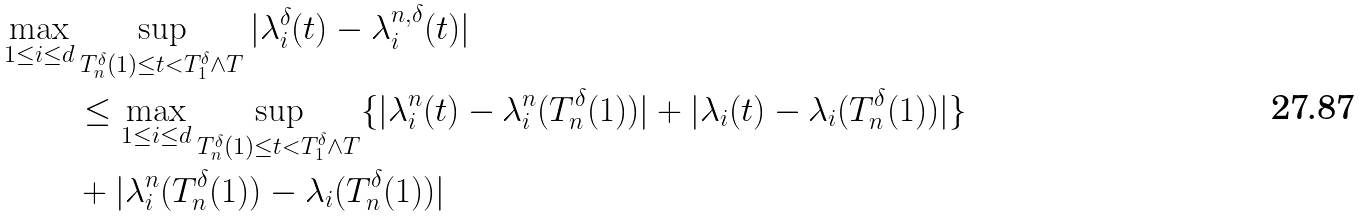Convert formula to latex. <formula><loc_0><loc_0><loc_500><loc_500>\max _ { 1 \leq i \leq d } & \sup _ { T _ { n } ^ { \delta } ( 1 ) \leq t < T _ { 1 } ^ { \delta } \wedge T } | \lambda _ { i } ^ { \delta } ( t ) - \lambda _ { i } ^ { n , \delta } ( t ) | \\ & \leq \max _ { 1 \leq i \leq d } \sup _ { T _ { n } ^ { \delta } ( 1 ) \leq t < T _ { 1 } ^ { \delta } \wedge T } \{ | \lambda _ { i } ^ { n } ( t ) - \lambda _ { i } ^ { n } ( T _ { n } ^ { \delta } ( 1 ) ) | + | \lambda _ { i } ( t ) - \lambda _ { i } ( T _ { n } ^ { \delta } ( 1 ) ) | \} \\ & + | \lambda _ { i } ^ { n } ( T _ { n } ^ { \delta } ( 1 ) ) - \lambda _ { i } ( T _ { n } ^ { \delta } ( 1 ) ) |</formula> 